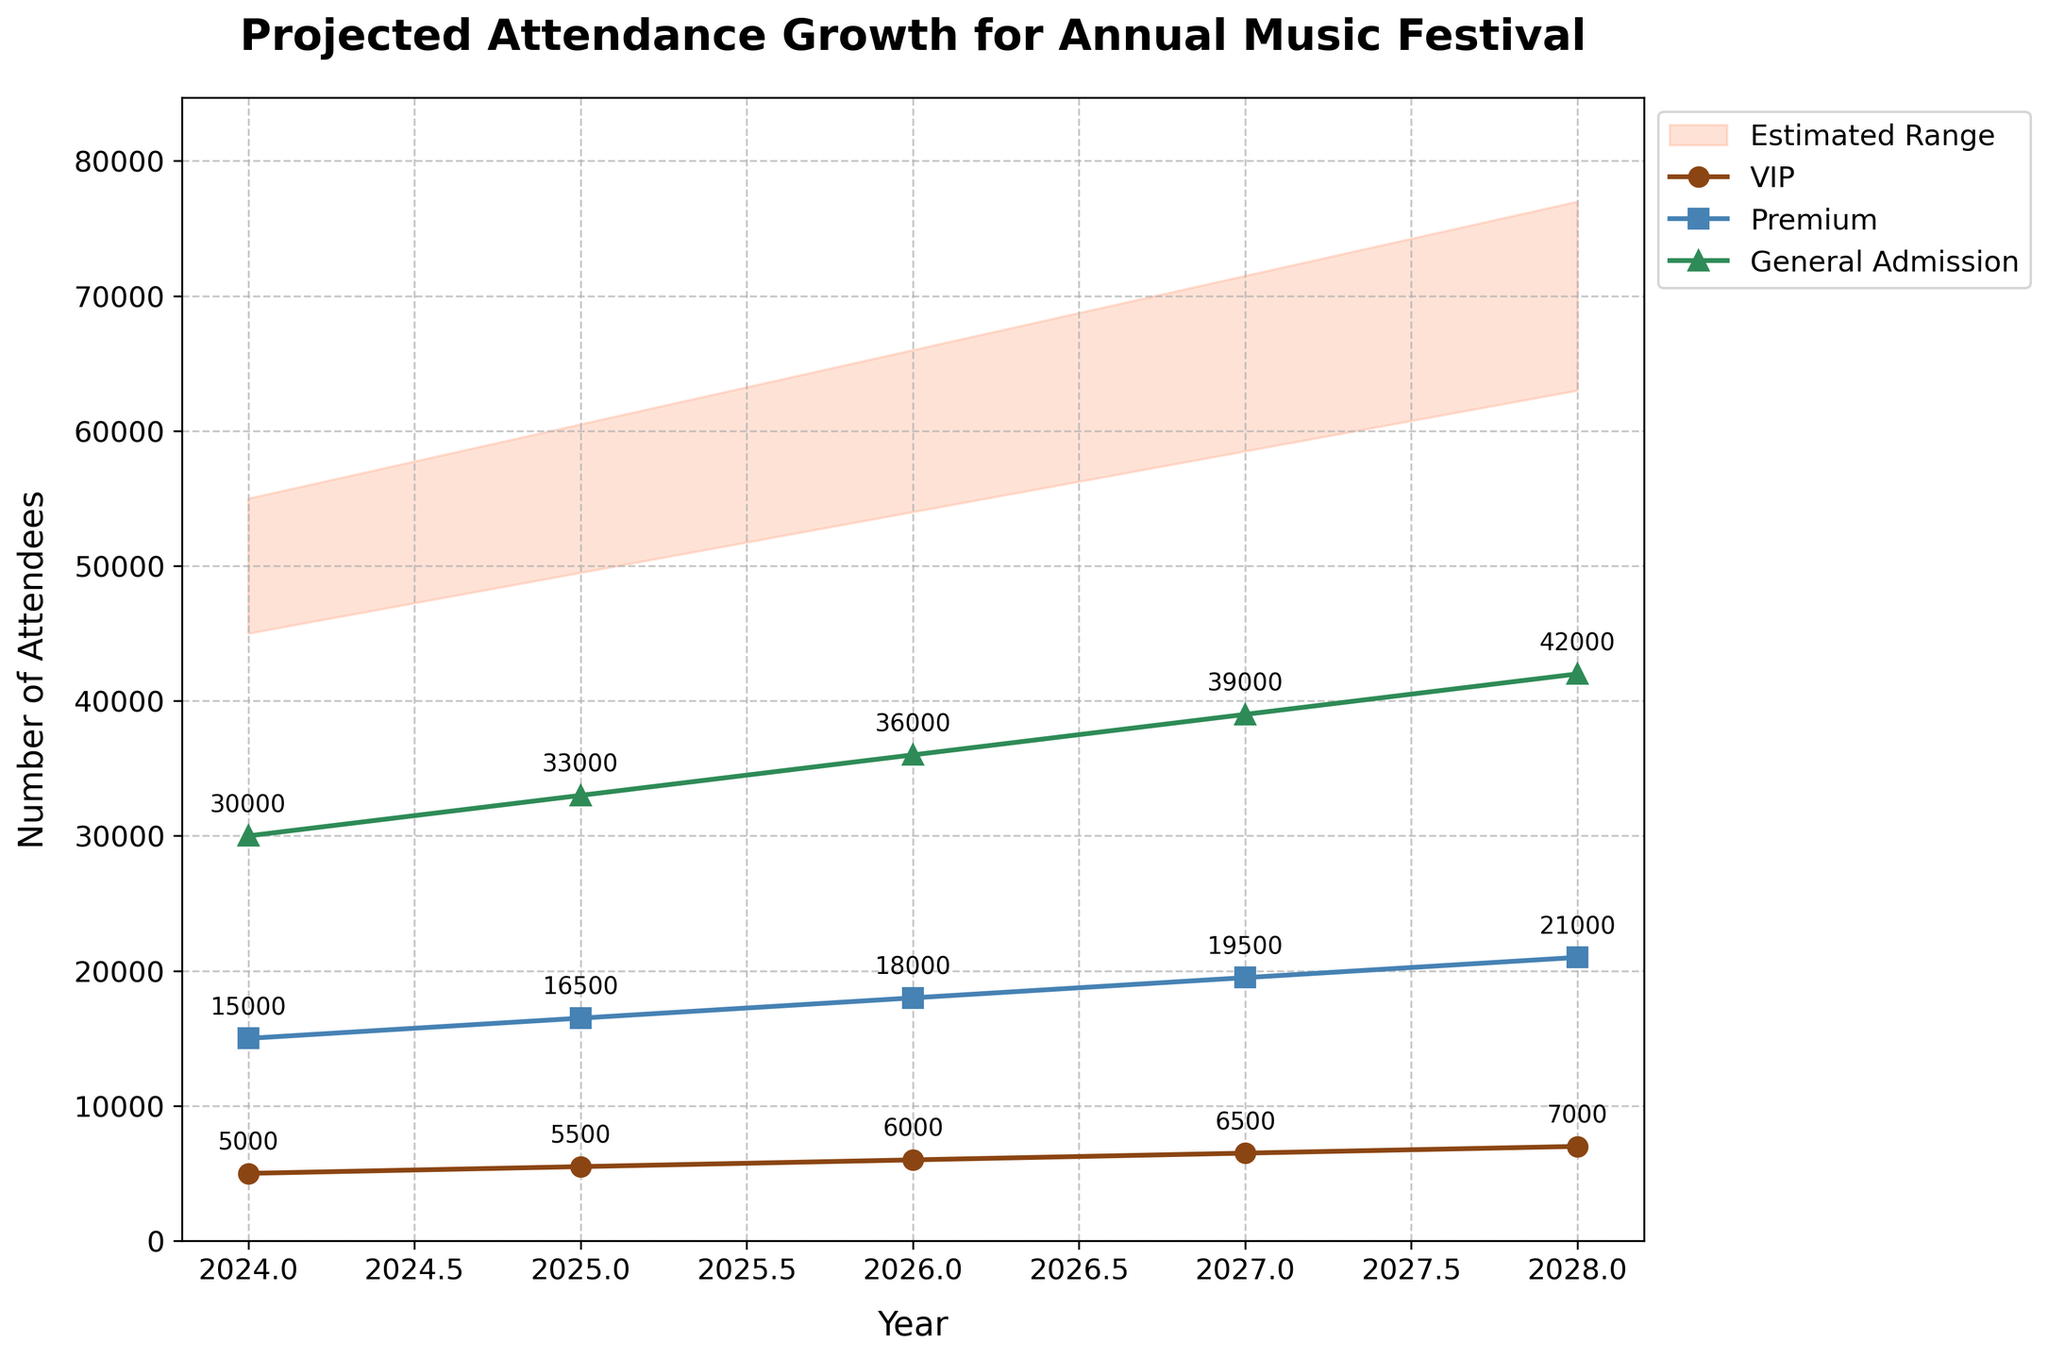What is the title of the chart? The title is generally displayed at the top of the chart, and in this case, it provides an overview of the chart’s subject.
Answer: Projected Attendance Growth for Annual Music Festival What ticket tier had the highest number of attendees in 2027? By looking at the values for each ticket tier in 2027, we can see that General Admission has the highest number.
Answer: General Admission What is the range of the estimated total attendance in 2025? The lower estimate in 2025 is 49,500 and the upper estimate is 60,500, so the range is calculated as the upper estimate minus the lower estimate.
Answer: 11,000 How much is the projected growth in VIP ticket sales from 2024 to 2028? The number of VIP tickets grows from 5,000 in 2024 to 7,000 in 2028. The growth is calculated by subtracting the initial value from the final value.
Answer: 2,000 Which ticket tier shows the most consistent growth pattern over the years? By examining the visual trend lines for each tier, VIP, Premium, and General Admission, all show a consistent growth pattern, but VIP has the most gradual and steady increase.
Answer: VIP What is the average number of Premium ticket sales between 2024 and 2028? The sales are 15,000, 16,500, 18,000, 19,500, and 21,000. Summing them gives 90,000, and dividing by 5 gives the average.
Answer: 18,000 In which year is the estimated range for total attendance the widest? By observing the fan chart and comparing the ranges (upper estimate minus lower estimate), the range in 2028 is the widest (77,000 - 63,000).
Answer: 2028 How many more General Admission tickets were sold compared to VIP tickets in 2026? In 2026, General Admission sold 36,000 tickets, while VIP sold 6,000. The difference is calculated by subtracting VIP tickets from General Admission tickets.
Answer: 30,000 By how much does the projected total number of attendees increase from 2024 to 2025? The estimated total number of attendees in 2024 ranges from 45,000 to 55,000, and in 2025 it ranges from 49,500 to 60,500. The increase is seen by comparing the lower and upper bounds.
Answer: 4,500 to 5,500 Which year represents the largest increase in Premium ticket sales? By observing the increments year by year, the increase from 18,000 to 19,500 (1,500) in 2027 is the largest.
Answer: 2027 